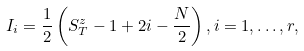<formula> <loc_0><loc_0><loc_500><loc_500>I _ { i } = \frac { 1 } { 2 } \left ( S _ { T } ^ { z } - 1 + 2 i - \frac { N } { 2 } \right ) , i = 1 , \dots , r ,</formula> 